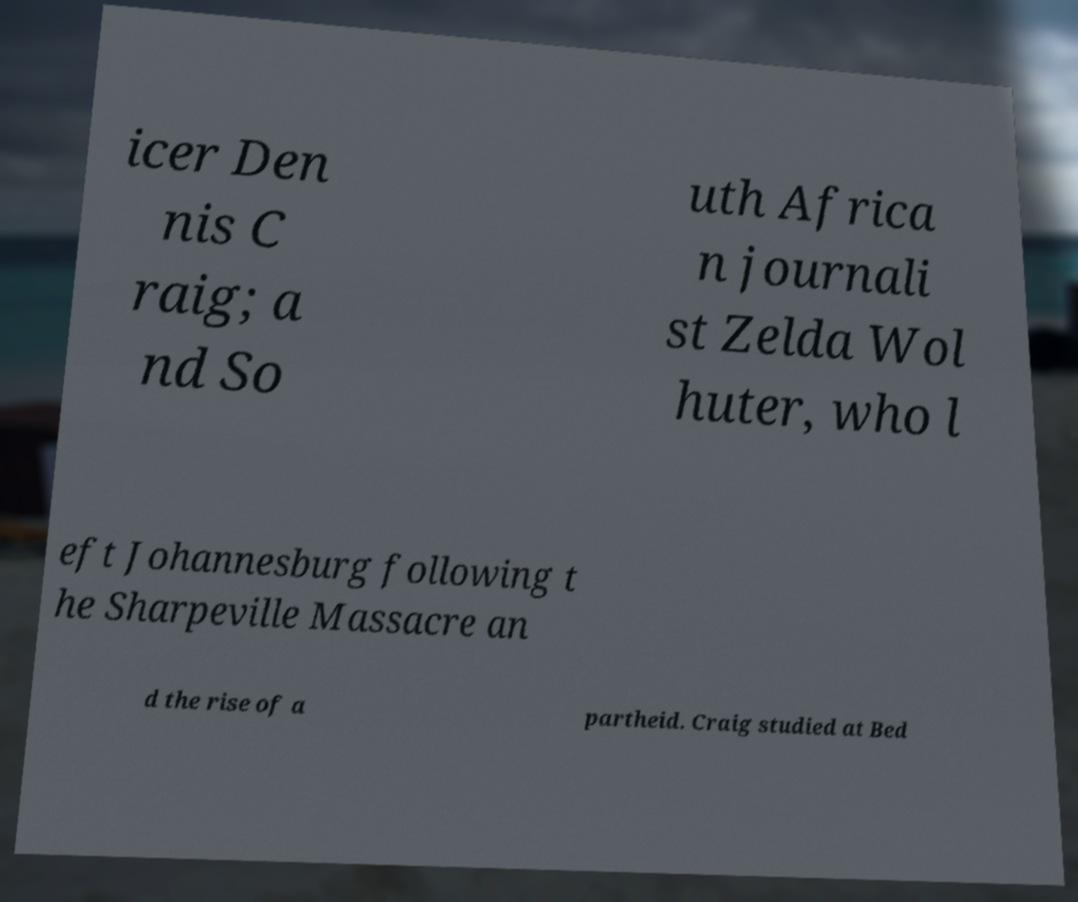I need the written content from this picture converted into text. Can you do that? icer Den nis C raig; a nd So uth Africa n journali st Zelda Wol huter, who l eft Johannesburg following t he Sharpeville Massacre an d the rise of a partheid. Craig studied at Bed 